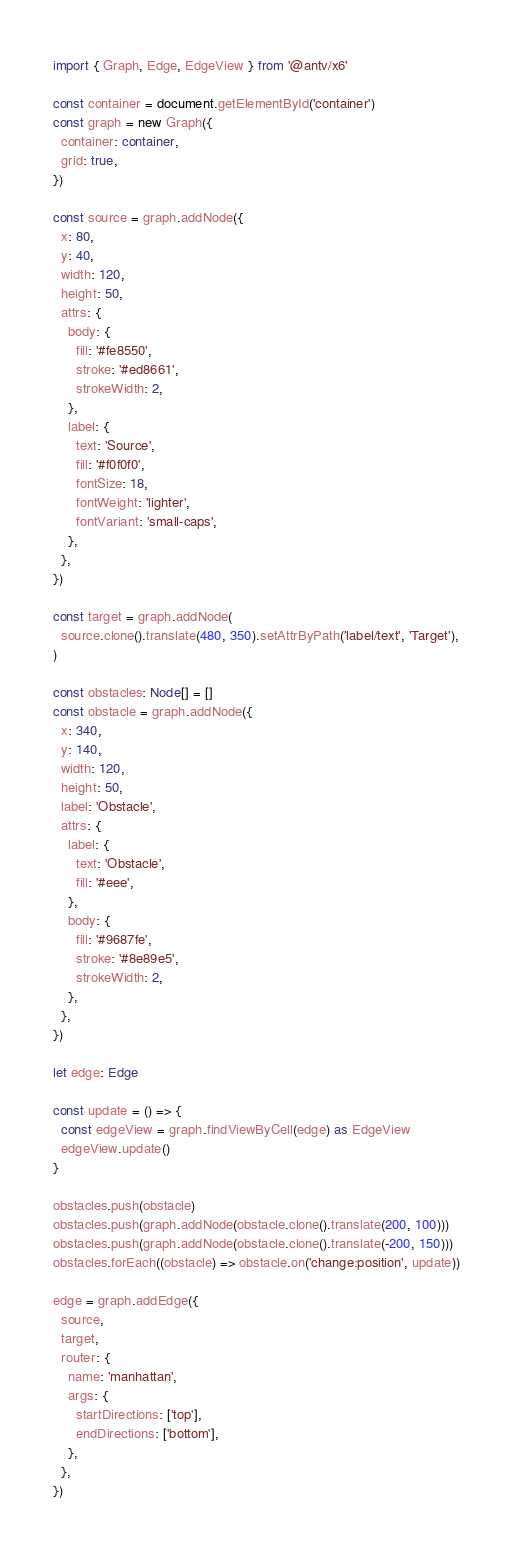Convert code to text. <code><loc_0><loc_0><loc_500><loc_500><_TypeScript_>import { Graph, Edge, EdgeView } from '@antv/x6'

const container = document.getElementById('container')
const graph = new Graph({
  container: container,
  grid: true,
})

const source = graph.addNode({
  x: 80,
  y: 40,
  width: 120,
  height: 50,
  attrs: {
    body: {
      fill: '#fe8550',
      stroke: '#ed8661',
      strokeWidth: 2,
    },
    label: {
      text: 'Source',
      fill: '#f0f0f0',
      fontSize: 18,
      fontWeight: 'lighter',
      fontVariant: 'small-caps',
    },
  },
})

const target = graph.addNode(
  source.clone().translate(480, 350).setAttrByPath('label/text', 'Target'),
)

const obstacles: Node[] = []
const obstacle = graph.addNode({
  x: 340,
  y: 140,
  width: 120,
  height: 50,
  label: 'Obstacle',
  attrs: {
    label: {
      text: 'Obstacle',
      fill: '#eee',
    },
    body: {
      fill: '#9687fe',
      stroke: '#8e89e5',
      strokeWidth: 2,
    },
  },
})

let edge: Edge

const update = () => {
  const edgeView = graph.findViewByCell(edge) as EdgeView
  edgeView.update()
}

obstacles.push(obstacle)
obstacles.push(graph.addNode(obstacle.clone().translate(200, 100)))
obstacles.push(graph.addNode(obstacle.clone().translate(-200, 150)))
obstacles.forEach((obstacle) => obstacle.on('change:position', update))

edge = graph.addEdge({
  source,
  target,
  router: {
    name: 'manhattan',
    args: {
      startDirections: ['top'],
      endDirections: ['bottom'],
    },
  },
})
</code> 